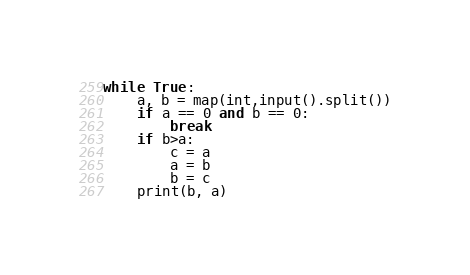Convert code to text. <code><loc_0><loc_0><loc_500><loc_500><_Python_>while True:
    a, b = map(int,input().split())
    if a == 0 and b == 0:
        break
    if b>a:
        c = a
        a = b
        b = c
    print(b, a)

</code> 